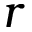<formula> <loc_0><loc_0><loc_500><loc_500>r</formula> 